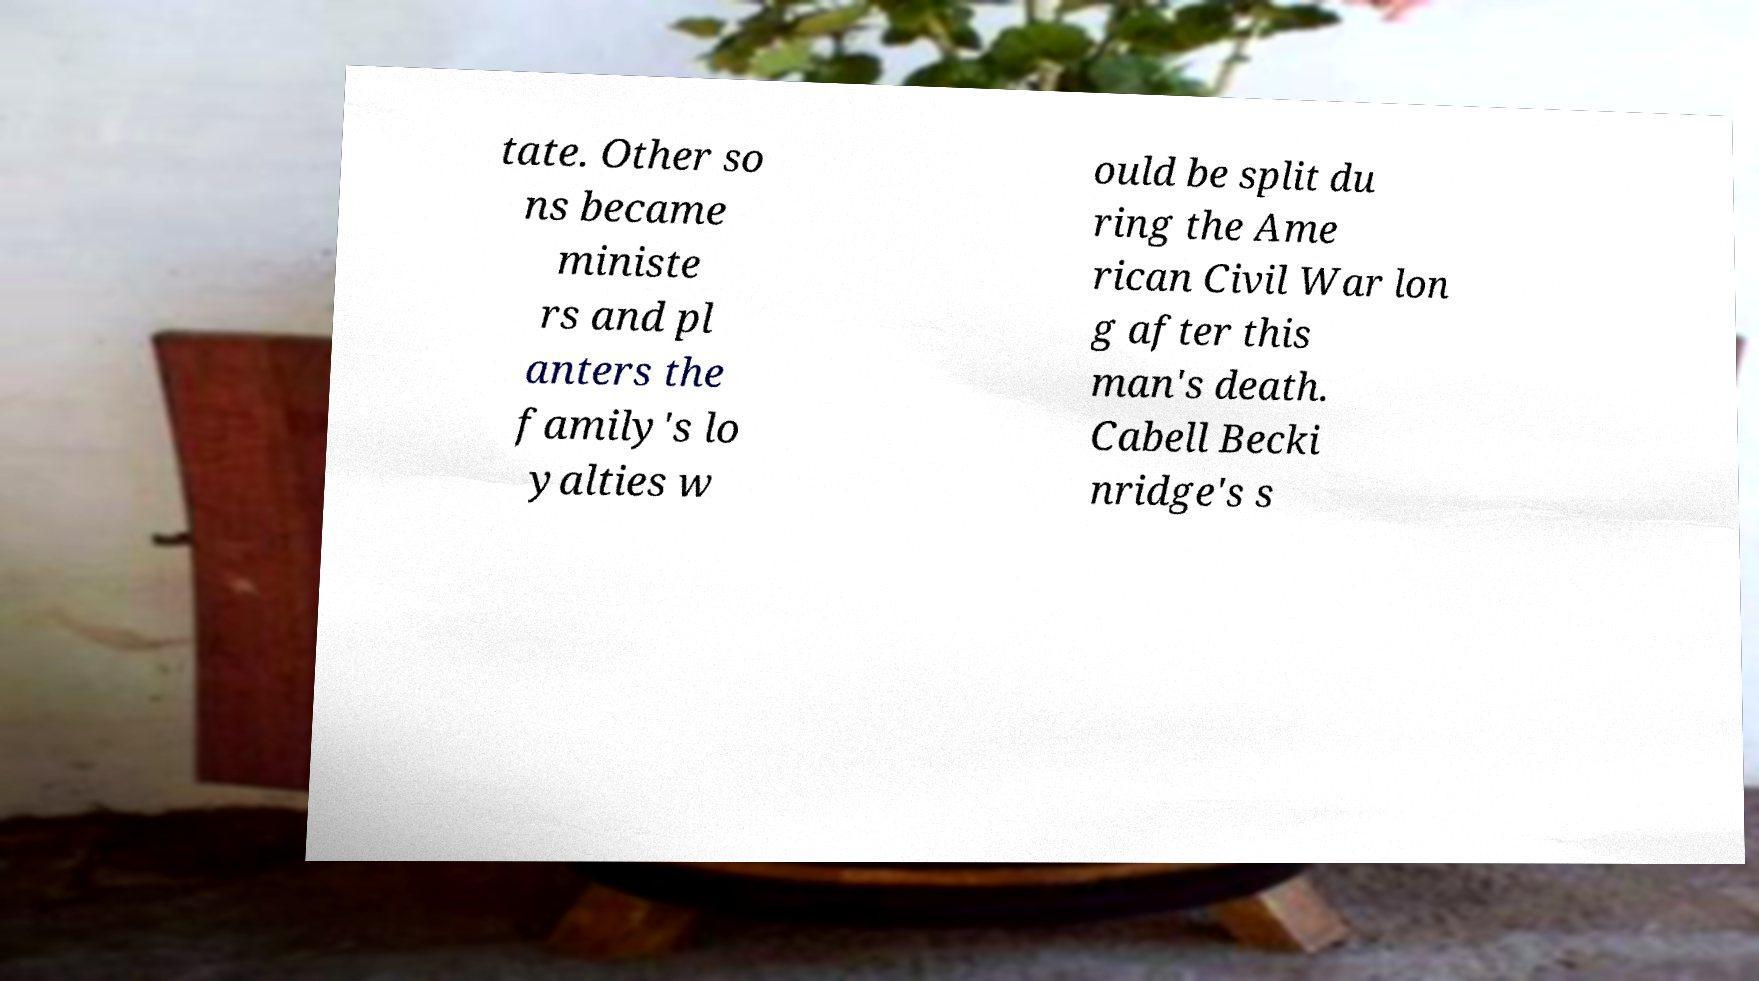I need the written content from this picture converted into text. Can you do that? tate. Other so ns became ministe rs and pl anters the family's lo yalties w ould be split du ring the Ame rican Civil War lon g after this man's death. Cabell Becki nridge's s 